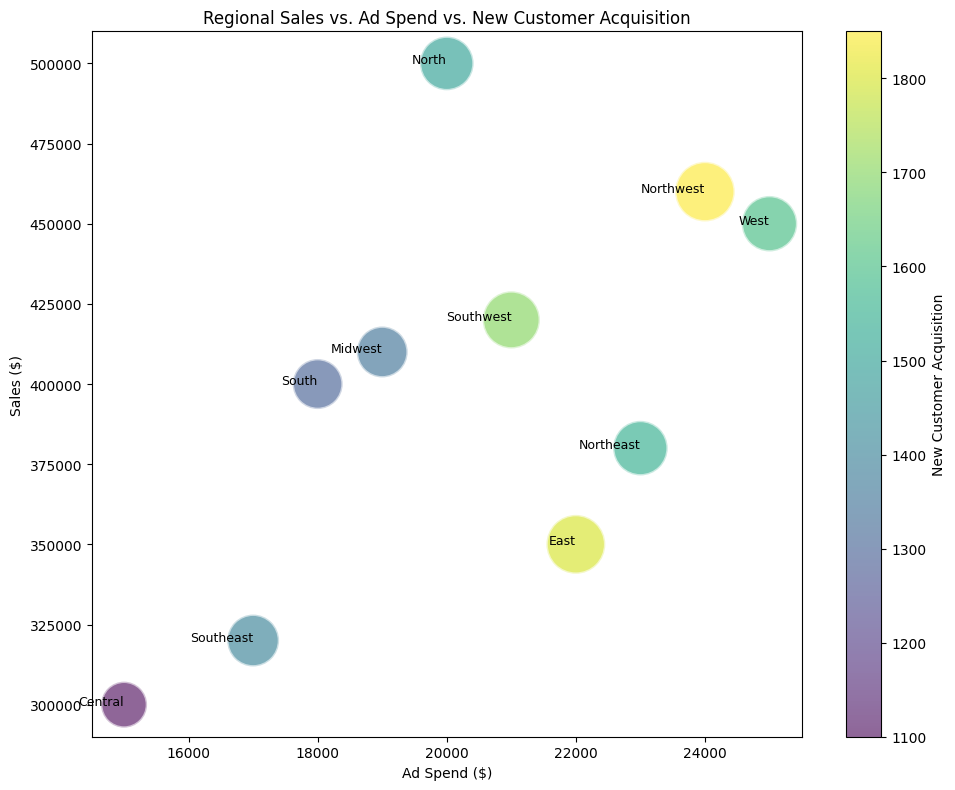What's the region with the highest Sales ($)? Looking at the y-axis for Sales ($) and identifying the highest point, we see that the "Northwest" region has the highest sales.
Answer: Northwest How does the Ad Spend in the East compare to the Ad Spend in the West? Reviewing the x-axis values for Ad Spend, the East region is at $22,000, while the West is at $25,000. Thus, the West's Ad Spend is higher.
Answer: West's Ad Spend is higher Which region has the most new customer acquisitions? Observing the bubble size as well as referring to the color bar, the region with the largest bubble and highest value on the color bar is the "Northwest" with 1850 new customers.
Answer: Northwest What's the total Sales ($) of the Central and Midwest regions combined? Central's Sales is $300,000 and Midwest's Sales is $410,000. Adding them together gives us $300,000 + $410,000 = $710,000.
Answer: $710,000 What's the region with the lowest Ad Spend? Checking the x-axis for the smallest value, the Central region has the lowest Ad Spend at $15,000.
Answer: Central If we increase the Ad Spend of Southeast to match West's, which region would then have the highest Ad Spend? Currently, West has the highest Ad Spend at $25,000. If Southeast also reaches $25,000 (from $17,000), either Southeast or West could be considered to have the highest Ad Spend. As they both would match, they tie for highest.
Answer: Southeast and West tie Compare the new customer acquisition rate of South to Northeast. By looking at the color intensity and bubble size, South has 1300 new customers and Northeast has 1550. Therefore, Northeast has a higher new customer acquisition rate.
Answer: Northeast's is higher Which two regions share the most similar Sales ($) figures? Checking the y-axis for closely aligned points, the South ($400,000) and Southwest ($420,000) regions have Sales figures closest to each other.
Answer: South and Southwest Which region needs the least amount of Ad Spend to attract a relatively high number of new customers? Looking at Ad Spend vs New Customer Acquisition, North has a lower Ad Spend ($20,000) yet a high number of new customers (1500), making it an efficient region for new customer acquisition.
Answer: North What's the average Sales ($) of all regions combined? Summing up all Sales figures: $500,000 + $400,000 + $350,000 + $450,000 + $300,000 + $320,000 + $420,000 + $380,000 + $460,000 + $410,000 = $3,990,000. Dividing by the number of regions, 10, gives an average of $3,990,000 / 10 = $399,000.
Answer: $399,000 